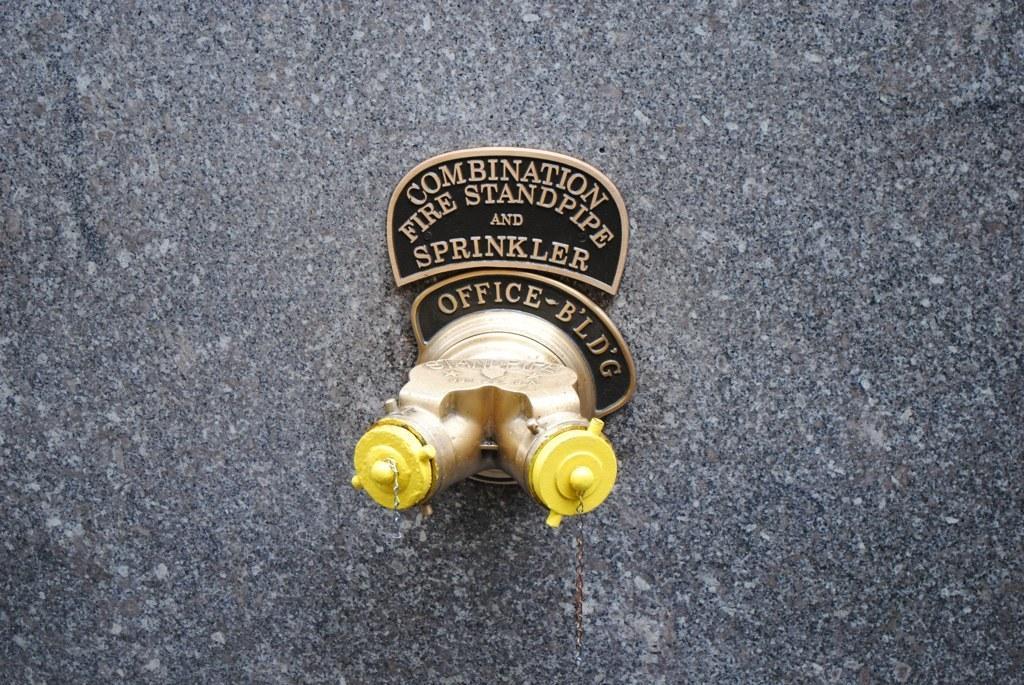Can you describe this image briefly? In this image I can see the wall which is white and black in color and to it I can see two pipes which are gold and yellow in color and a board attached to the wall which is black and gold in color. 